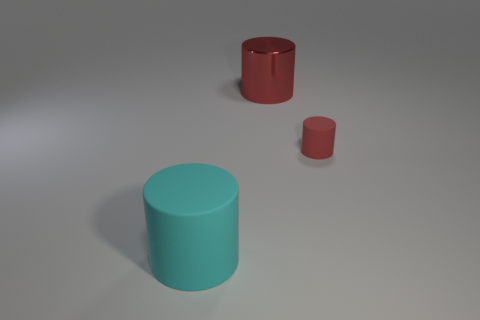Add 3 large metallic cylinders. How many objects exist? 6 Subtract 0 blue cylinders. How many objects are left? 3 Subtract all small red rubber cylinders. Subtract all big cyan matte cylinders. How many objects are left? 1 Add 1 big cyan cylinders. How many big cyan cylinders are left? 2 Add 3 big gray blocks. How many big gray blocks exist? 3 